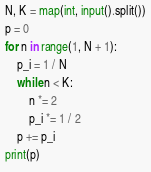Convert code to text. <code><loc_0><loc_0><loc_500><loc_500><_Python_>N, K = map(int, input().split())
p = 0
for n in range(1, N + 1):
    p_i = 1 / N
    while n < K:
        n *= 2
        p_i *= 1 / 2
    p += p_i
print(p)</code> 